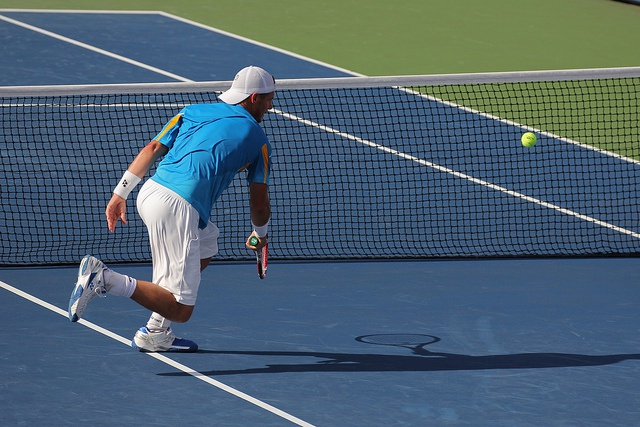Describe the objects in this image and their specific colors. I can see people in olive, lightgray, lightblue, darkgray, and black tones, tennis racket in olive, black, gray, brown, and maroon tones, and sports ball in olive, khaki, and green tones in this image. 